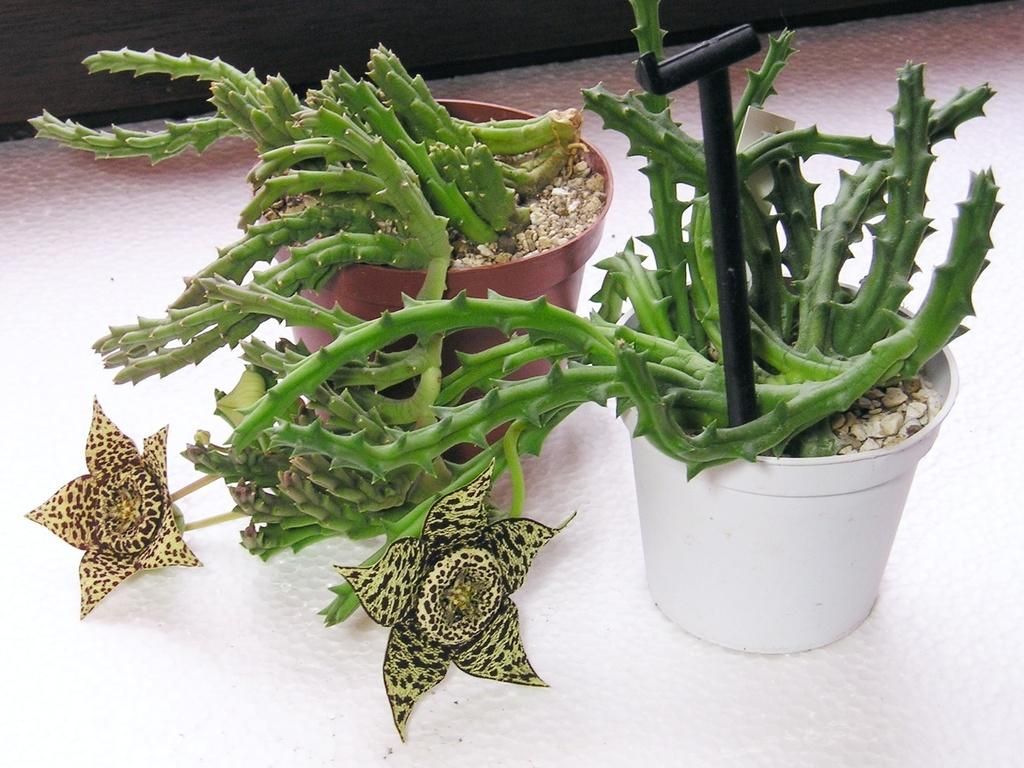What type of plants are in the image? There are cactus plants in the image. How are the cactus plants arranged or placed? The cactus plants are placed in flower pots. Are there any other types of plants or flowers in the image? Yes, there are flowers in the image. What is the distance between the cactus plants and the bed in the image? There is no bed present in the image, so it is not possible to determine the distance between the cactus plants and a bed. 